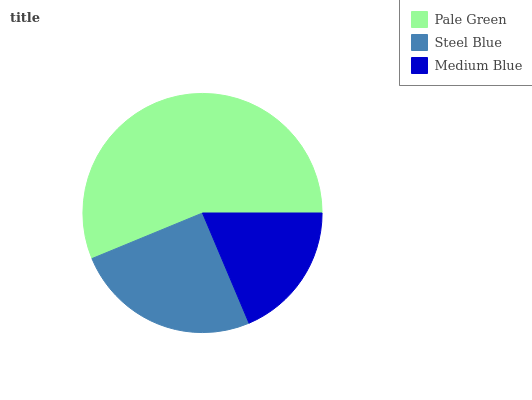Is Medium Blue the minimum?
Answer yes or no. Yes. Is Pale Green the maximum?
Answer yes or no. Yes. Is Steel Blue the minimum?
Answer yes or no. No. Is Steel Blue the maximum?
Answer yes or no. No. Is Pale Green greater than Steel Blue?
Answer yes or no. Yes. Is Steel Blue less than Pale Green?
Answer yes or no. Yes. Is Steel Blue greater than Pale Green?
Answer yes or no. No. Is Pale Green less than Steel Blue?
Answer yes or no. No. Is Steel Blue the high median?
Answer yes or no. Yes. Is Steel Blue the low median?
Answer yes or no. Yes. Is Medium Blue the high median?
Answer yes or no. No. Is Pale Green the low median?
Answer yes or no. No. 